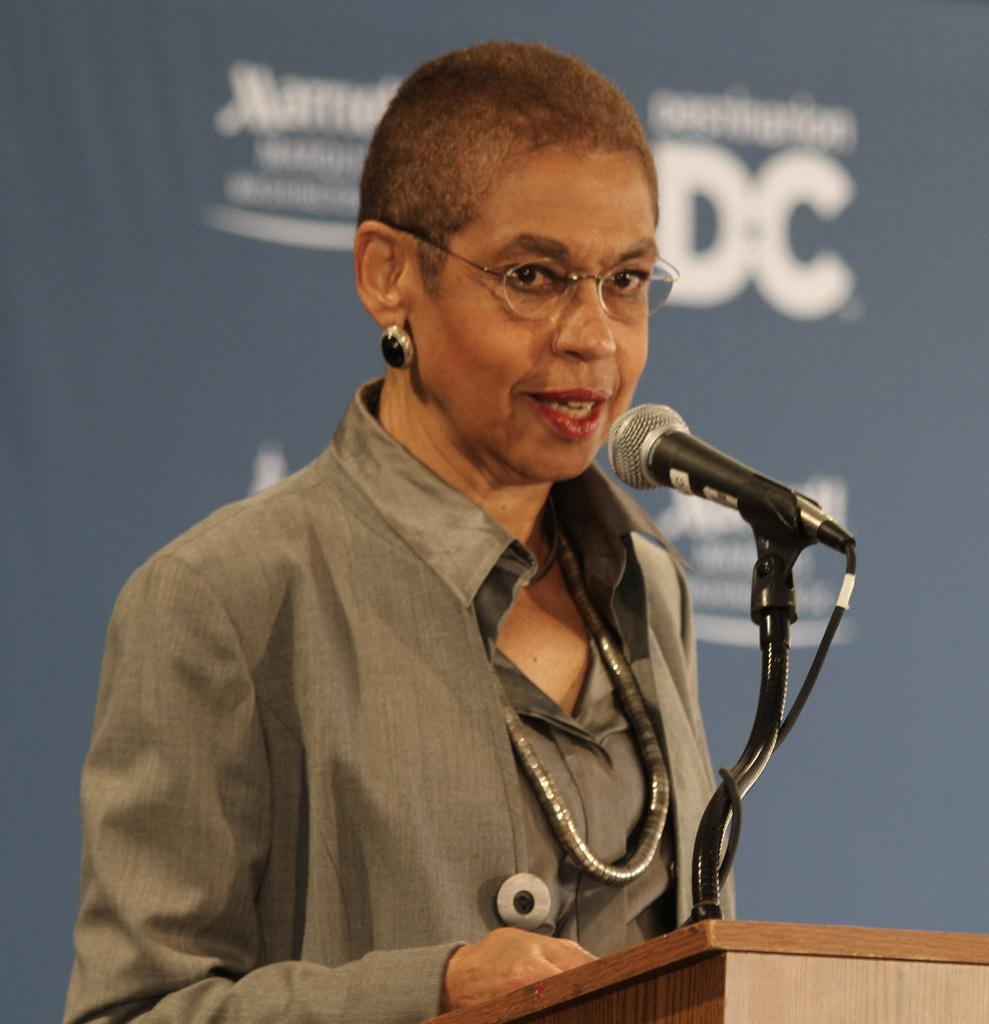Who is the main subject in the image? There is a woman in the image. What is the woman wearing? The woman is wearing spectacles. What is the woman doing in the image? The woman is standing at a podium and speaking into a microphone. What can be seen in the background of the image? There is a banner visible in the background of the image. How does the woman drop a caption in the image? There is no caption present in the image, and therefore the woman cannot drop one. What type of jump can be seen in the image? There is no jumping activity depicted in the image; the woman is standing at a podium and speaking into a microphone. 